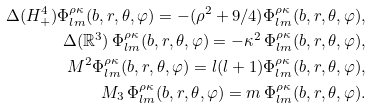<formula> <loc_0><loc_0><loc_500><loc_500>\Delta ( H ^ { 4 } _ { + } ) \Phi ^ { \rho \kappa } _ { l m } ( b , r , \theta , \varphi ) = - ( \rho ^ { 2 } + 9 / 4 ) \Phi ^ { \rho \kappa } _ { l m } ( b , r , \theta , \varphi ) , \\ \Delta ( \mathbb { R } ^ { 3 } ) \, \Phi ^ { \rho \kappa } _ { l m } ( b , r , \theta , \varphi ) = - \kappa ^ { 2 } \, \Phi ^ { \rho \kappa } _ { l m } ( b , r , \theta , \varphi ) , \\ { M } ^ { 2 } \Phi ^ { \rho \kappa } _ { l m } ( b , r , \theta , \varphi ) = l ( l + 1 ) \Phi ^ { \rho \kappa } _ { l m } ( b , r , \theta , \varphi ) , \\ M _ { 3 } \, \Phi ^ { \rho \kappa } _ { l m } ( b , r , \theta , \varphi ) = m \, \Phi ^ { \rho \kappa } _ { l m } ( b , r , \theta , \varphi ) .</formula> 